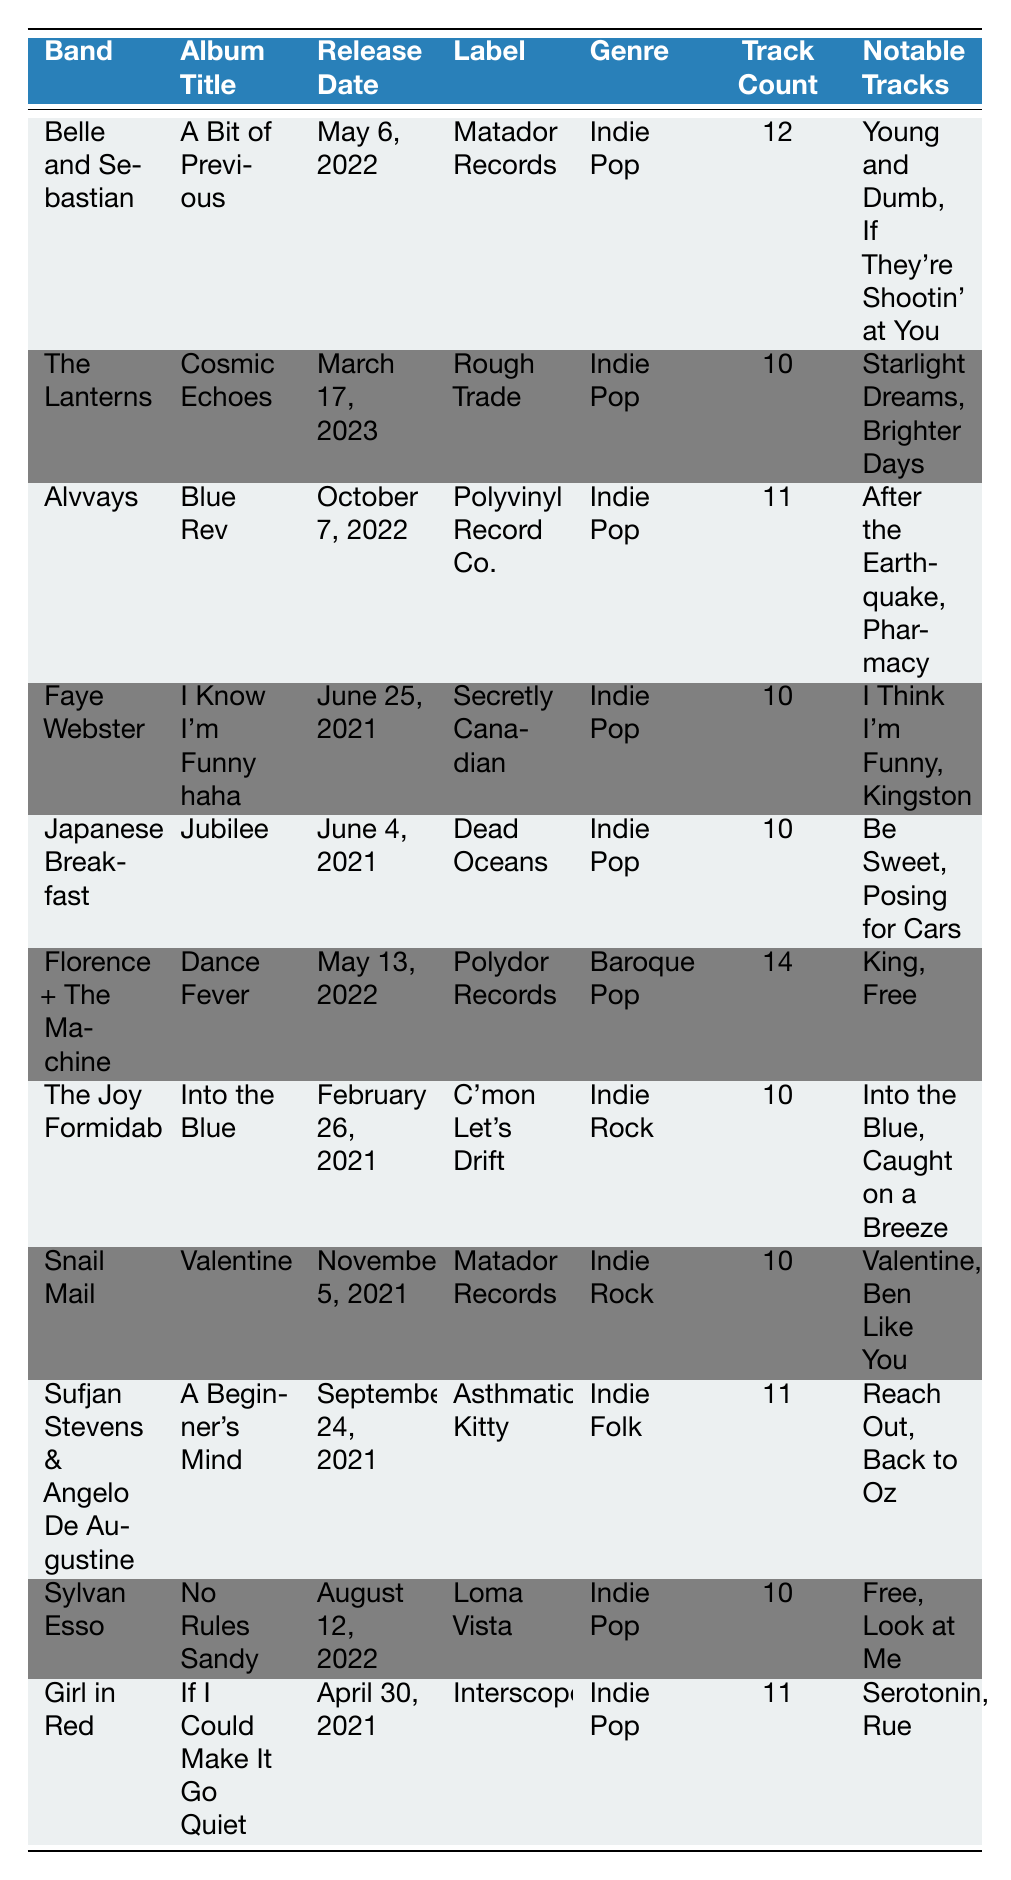What is the release date of "Cosmic Echoes"? The table lists the release date for "Cosmic Echoes" by The Lanterns as March 17, 2023.
Answer: March 17, 2023 Which band released an album in 2023? The table indicates that The Lanterns released "Cosmic Echoes" in 2023.
Answer: The Lanterns How many tracks are in "A Bit of Previous"? The table shows that Belle and Sebastian's album "A Bit of Previous" has 12 tracks.
Answer: 12 Do any albums listed in the table belong to the genre "Baroque Pop"? According to the table, "Dance Fever" by Florence + The Machine is categorized as Baroque Pop.
Answer: Yes What is the total number of notable tracks across all listed albums? The notable tracks are counted for each album: 2 (The Lanterns) + 2 (Belle and Sebastian) + 2 (Alvvays) + 2 (Faye Webster) + 2 (Japanese Breakfast) + 2 (Florence + The Machine) + 2 (The Joy Formidable) + 2 (Snail Mail) + 2 (Sylvan Esso) + 2 (Girl in Red) = 20 notable tracks.
Answer: 20 How many albums in the table have a track count greater than 10? From the table, "A Bit of Previous" has 12 tracks, "Blue Rev" has 11 tracks, and "If I Could Make It Go Quiet" has 11 tracks, which totals 3 albums with more than 10 tracks.
Answer: 3 Who released the album with the highest track count, and what is that count? "Dance Fever" by Florence + The Machine has the highest track count of 14, as shown in the table.
Answer: Florence + The Machine, 14 Is there an album released in April 2021? The table indicates that "If I Could Make It Go Quiet" by Girl in Red was released on April 30, 2021.
Answer: Yes What genre is "Jubilee" classified under? The table indicates that "Jubilee" by Japanese Breakfast is classified as Indie Pop.
Answer: Indie Pop Which album by an indie pop band was released first in 2023? According to the table, "Cosmic Echoes" by The Lanterns, released on March 17, 2023, is the only 2023 release listed here.
Answer: "Cosmic Echoes" by The Lanterns 